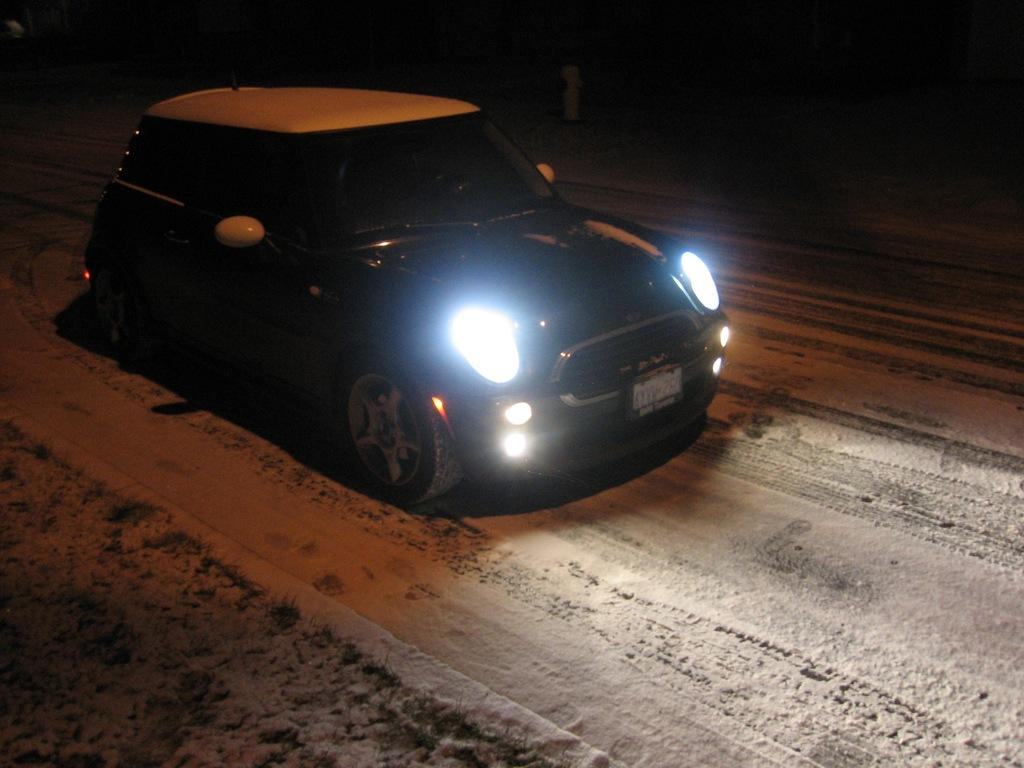What is the main subject of the image? The main subject of the image is a car. Where is the car located in the image? The car is on the road. What type of door can be seen on the back of the car in the image? There is no door visible on the back of the car in the image. Where is the car's home located in the image? The image does not show the car's home; it only shows the car on the road. 